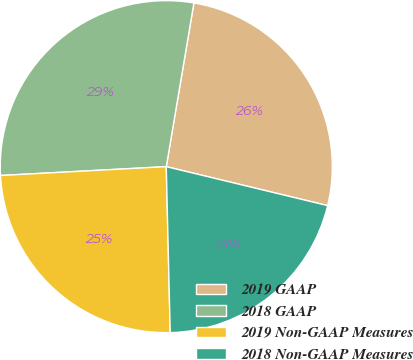Convert chart. <chart><loc_0><loc_0><loc_500><loc_500><pie_chart><fcel>2019 GAAP<fcel>2018 GAAP<fcel>2019 Non-GAAP Measures<fcel>2018 Non-GAAP Measures<nl><fcel>26.11%<fcel>28.51%<fcel>24.53%<fcel>20.85%<nl></chart> 